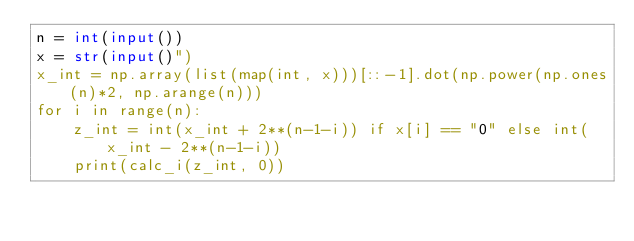<code> <loc_0><loc_0><loc_500><loc_500><_Python_>n = int(input())
x = str(input()")
x_int = np.array(list(map(int, x)))[::-1].dot(np.power(np.ones(n)*2, np.arange(n)))
for i in range(n):
    z_int = int(x_int + 2**(n-1-i)) if x[i] == "0" else int(x_int - 2**(n-1-i))
    print(calc_i(z_int, 0))</code> 